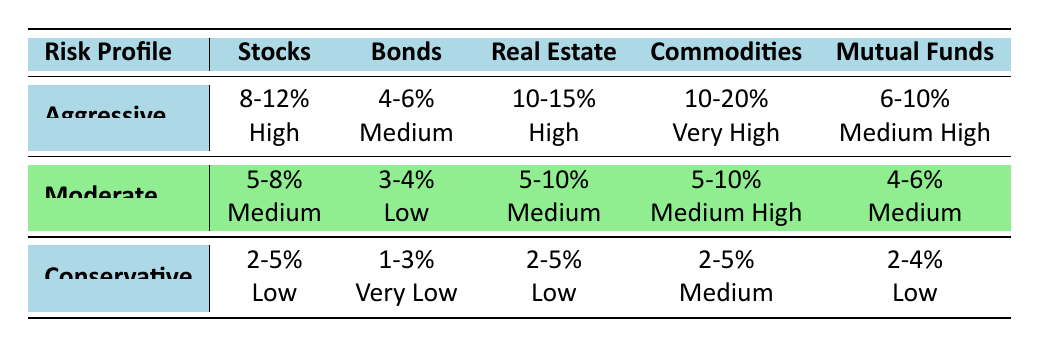What is the expected return for an aggressive risk profile in Stocks? The table lists the expected return for Stocks under the aggressive risk profile as 8-12%.
Answer: 8-12% Which asset class has the highest expected return for a conservative risk profile? The expected return for conservative risk profiles across asset classes is 2-5% for Stocks, Real Estate, and Commodities, while Bonds has 1-3%. So Stocks, Real Estate, and Commodities tie for the highest at 2-5%.
Answer: Stocks, Real Estate, Commodities (2-5%) What is the volatility associated with Mutual Funds in a moderate risk profile? The table shows that for Mutual Funds under a moderate risk profile, the volatility is categorized as Medium.
Answer: Medium Is the expected return for aggressive Commodities higher than that of aggressive Real Estate? The expected return for aggressive Commodities is listed as 10-20%, while aggressive Real Estate provides 10-15%. Since 10-20% is greater than 10-15%, the statement is true.
Answer: Yes What is the average expected return for a moderate risk profile across all asset classes? The expected returns for moderate profiles from all asset classes are: Stocks (5-8%), Bonds (3-4%), Real Estate (5-10%), Commodities (5-10%), Mutual Funds (4-6%). Calculating the averages: (6.5 + 3.5 + 7.5 + 7.5 + 5) = 30/5 = 6.0%.
Answer: 6.0% Which asset class shows the lowest volatility for a conservative risk profile? According to the table, Bonds have the lowest volatility for a conservative risk profile, described as Very Low.
Answer: Bonds For which risk profile is the expected return between 10% and 15% in Real Estate? The table indicates that Real Estate offers an expected return of 10-15% for the aggressive risk profile. Hence, the answer is aggressive.
Answer: Aggressive What would be the total expected return range for an aggressive risk profile across Stocks and Real Estate? The expected return for aggressive Stocks is 8-12% and for aggressive Real Estate is 10-15%. Therefore, the total expected return range would be (8+10)-(12+15) = 18-27%.
Answer: 18-27% What is the volatility level for Bonds in a conservative risk profile? The table indicates that for Bonds under a conservative risk profile, the volatility is described as Very Low.
Answer: Very Low 